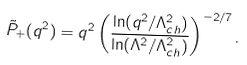Convert formula to latex. <formula><loc_0><loc_0><loc_500><loc_500>\tilde { P } _ { + } ( q ^ { 2 } ) = q ^ { 2 } \left ( \frac { \ln ( q ^ { 2 } / \Lambda ^ { 2 } _ { c h } ) } { \ln ( \Lambda ^ { 2 } / \Lambda ^ { 2 } _ { c h } ) } \right ) ^ { - 2 / 7 } .</formula> 